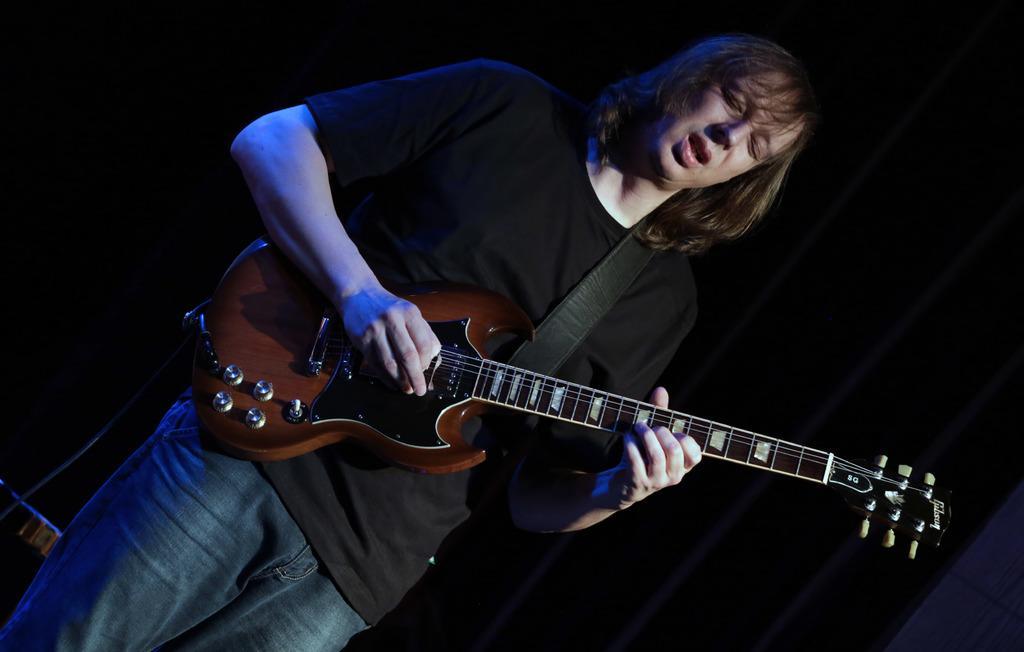Please provide a concise description of this image. Here is a person playing guitar which is of brown color that is held around his shoulders, his mouth is open so he is singing,he closed his eyes, he wore blue color jean. 